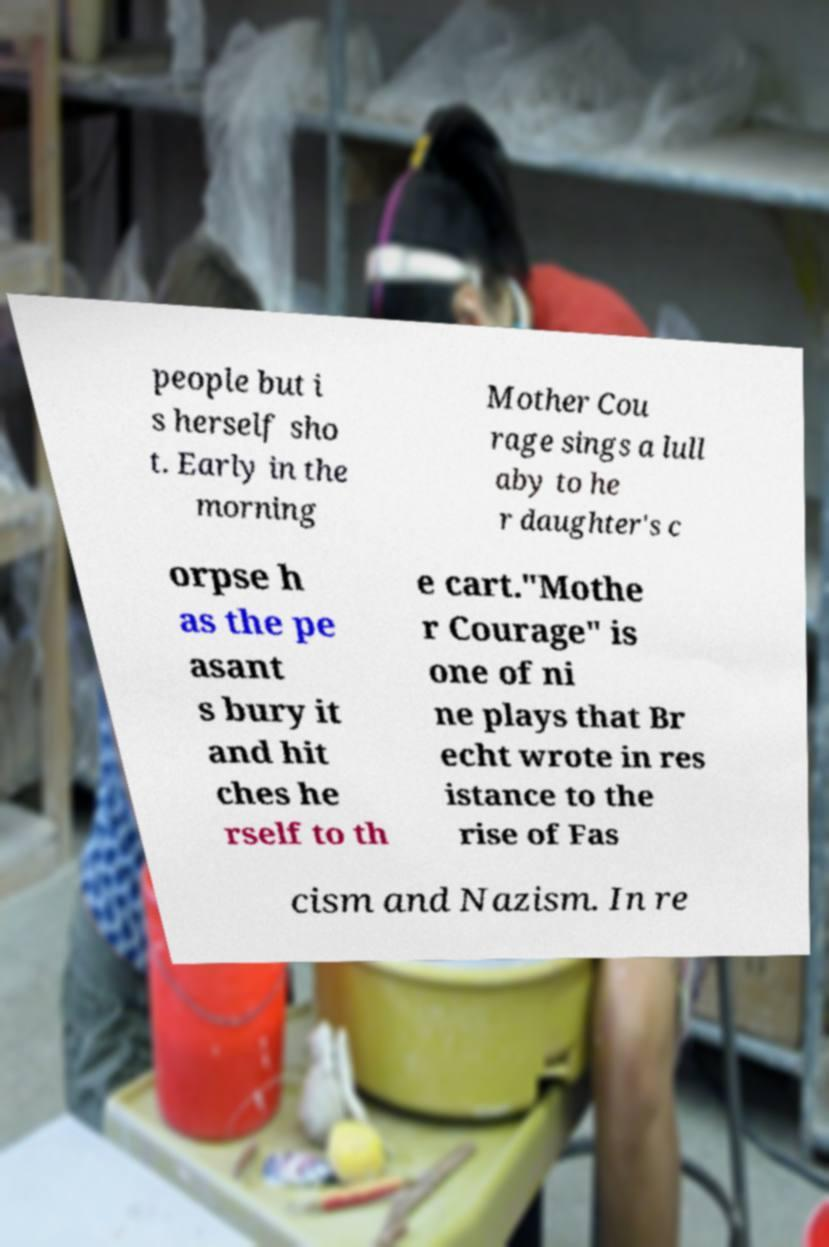Please identify and transcribe the text found in this image. people but i s herself sho t. Early in the morning Mother Cou rage sings a lull aby to he r daughter's c orpse h as the pe asant s bury it and hit ches he rself to th e cart."Mothe r Courage" is one of ni ne plays that Br echt wrote in res istance to the rise of Fas cism and Nazism. In re 